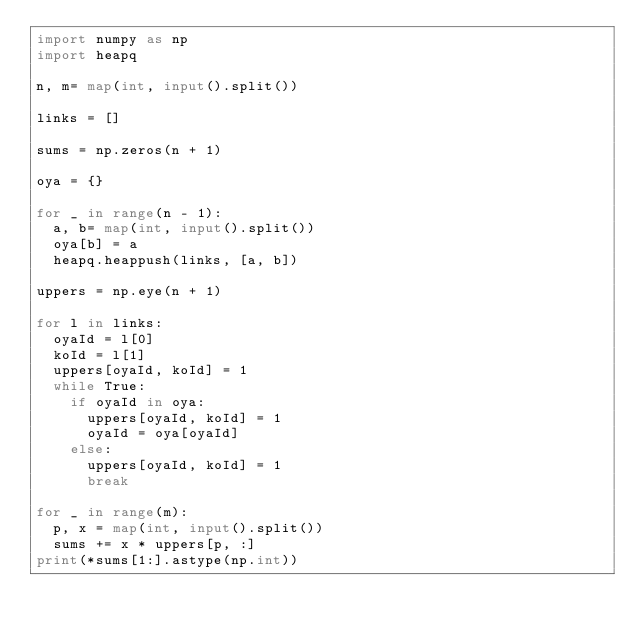<code> <loc_0><loc_0><loc_500><loc_500><_Python_>import numpy as np
import heapq

n, m= map(int, input().split())

links = []

sums = np.zeros(n + 1)

oya = {}

for _ in range(n - 1):
  a, b= map(int, input().split())
  oya[b] = a
  heapq.heappush(links, [a, b])

uppers = np.eye(n + 1)

for l in links:
  oyaId = l[0]
  koId = l[1]
  uppers[oyaId, koId] = 1
  while True: 
    if oyaId in oya:
      uppers[oyaId, koId] = 1
      oyaId = oya[oyaId]
    else:
      uppers[oyaId, koId] = 1
      break
      
for _ in range(m):
  p, x = map(int, input().split())
  sums += x * uppers[p, :]
print(*sums[1:].astype(np.int))
  </code> 